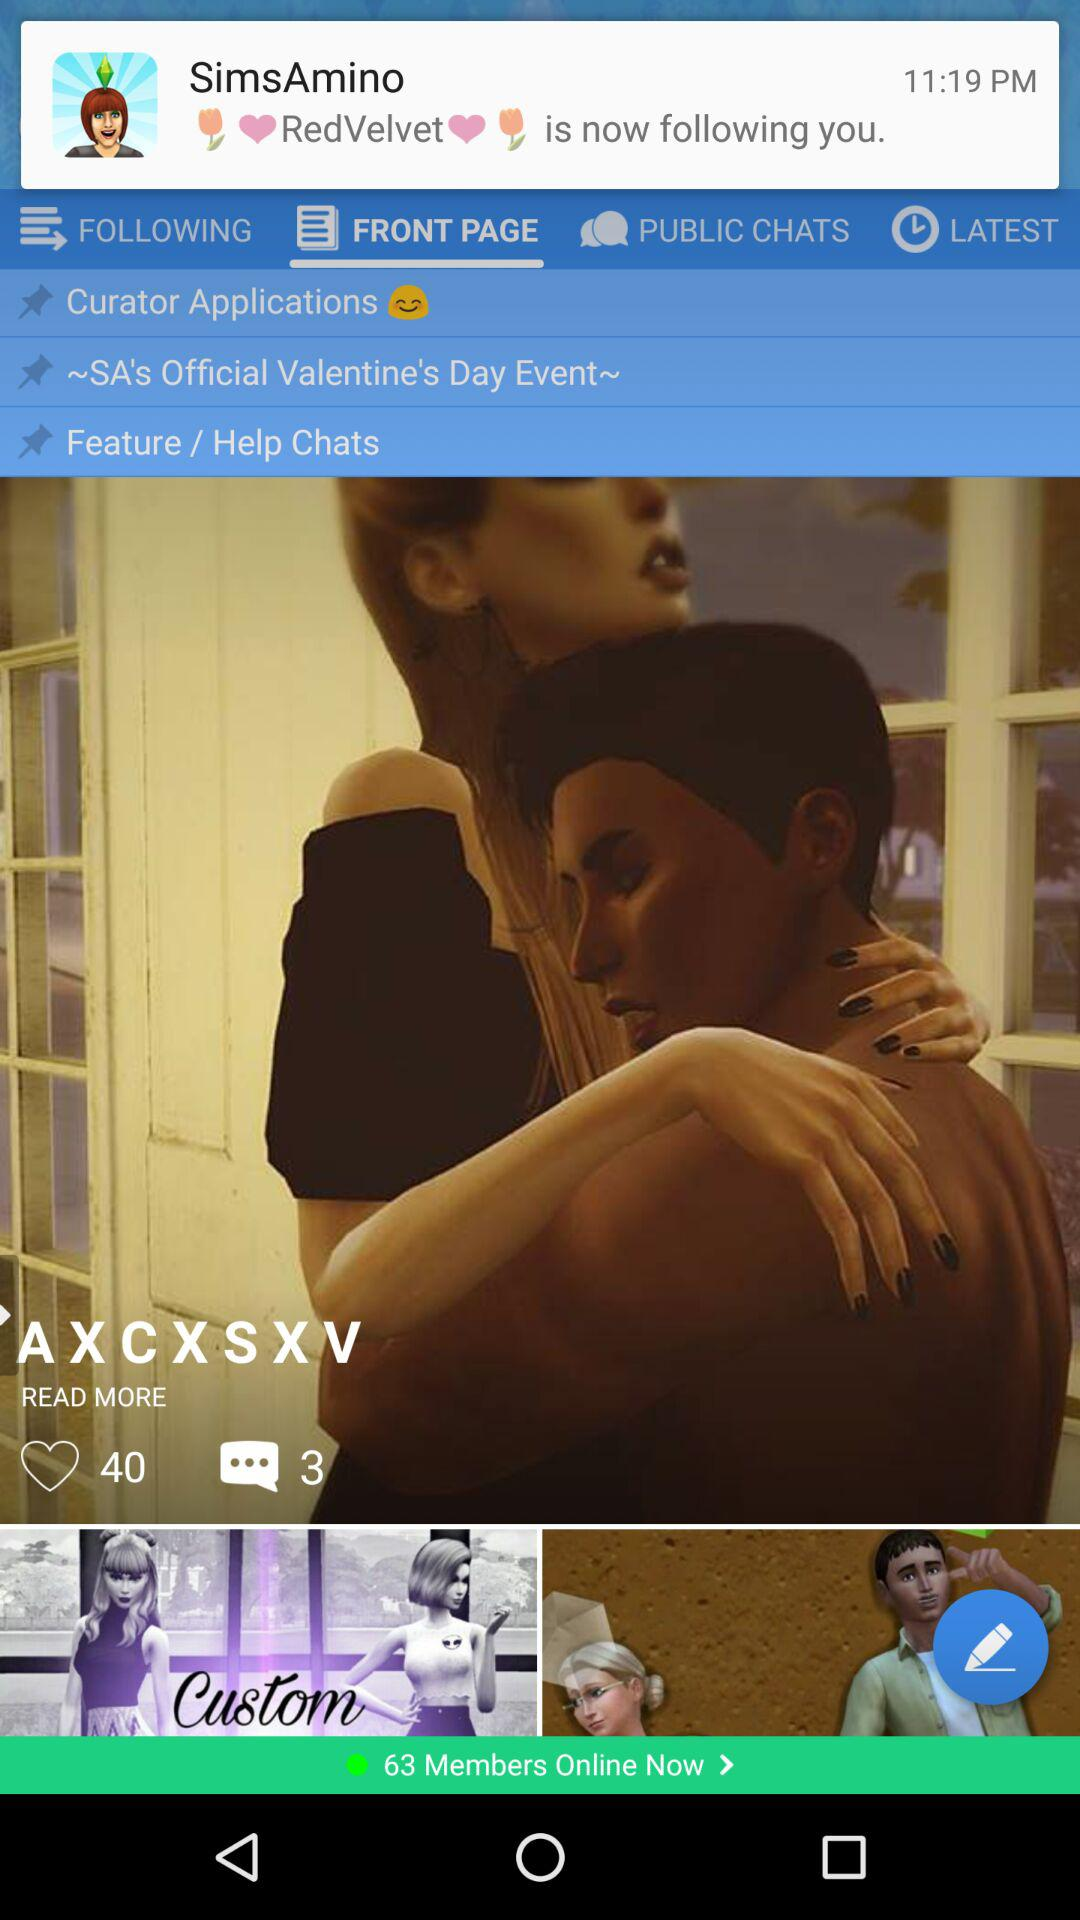How many members are online now? There are 63 members online now. 